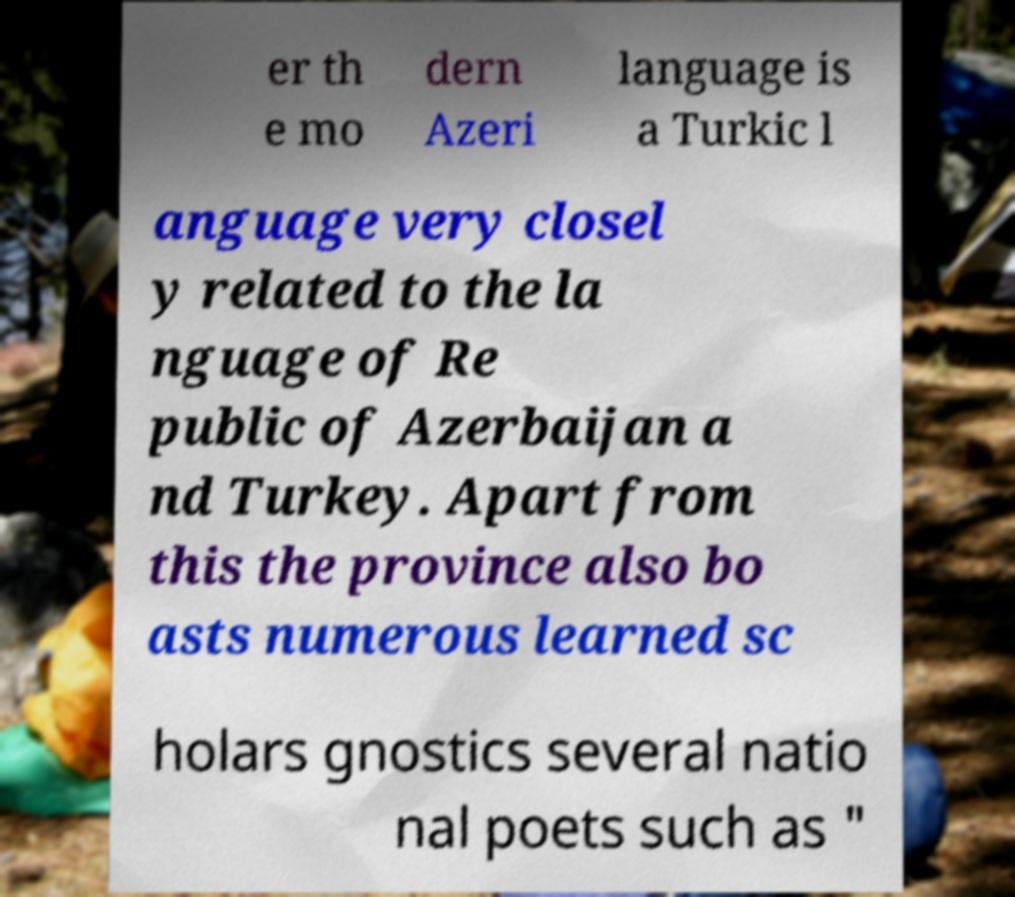Can you read and provide the text displayed in the image?This photo seems to have some interesting text. Can you extract and type it out for me? er th e mo dern Azeri language is a Turkic l anguage very closel y related to the la nguage of Re public of Azerbaijan a nd Turkey. Apart from this the province also bo asts numerous learned sc holars gnostics several natio nal poets such as " 